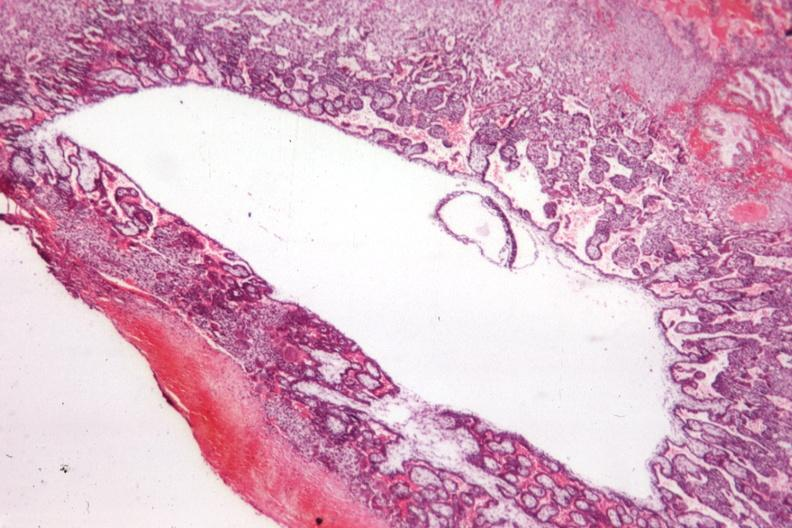s fetus developing very early present?
Answer the question using a single word or phrase. Yes 